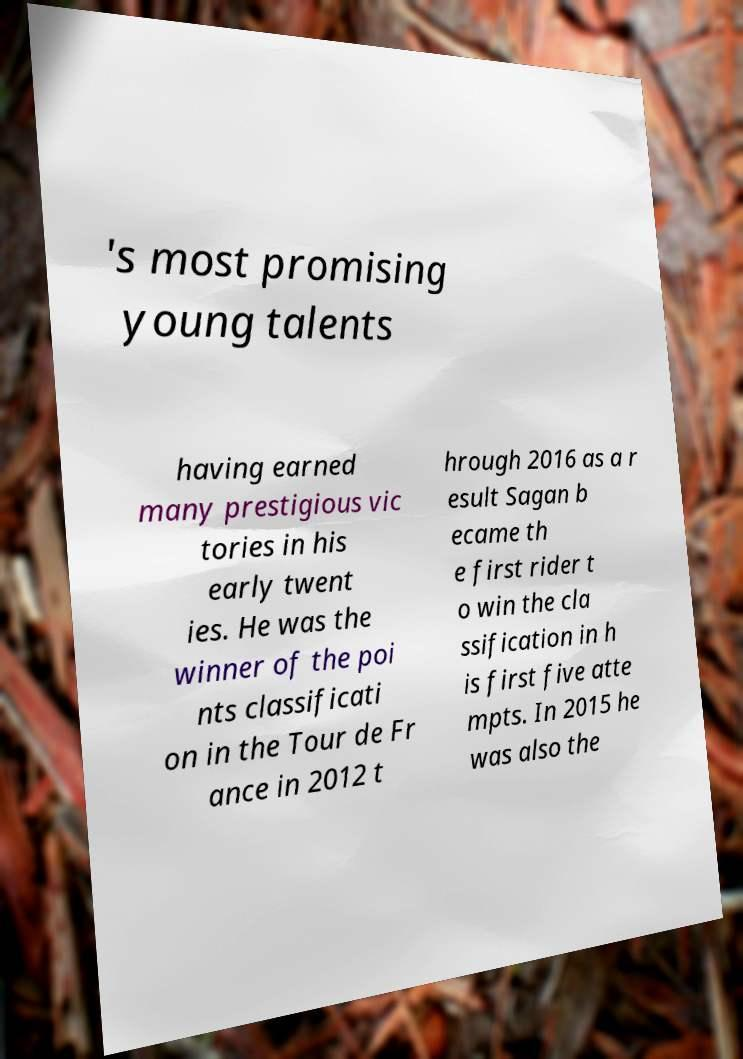Please identify and transcribe the text found in this image. 's most promising young talents having earned many prestigious vic tories in his early twent ies. He was the winner of the poi nts classificati on in the Tour de Fr ance in 2012 t hrough 2016 as a r esult Sagan b ecame th e first rider t o win the cla ssification in h is first five atte mpts. In 2015 he was also the 